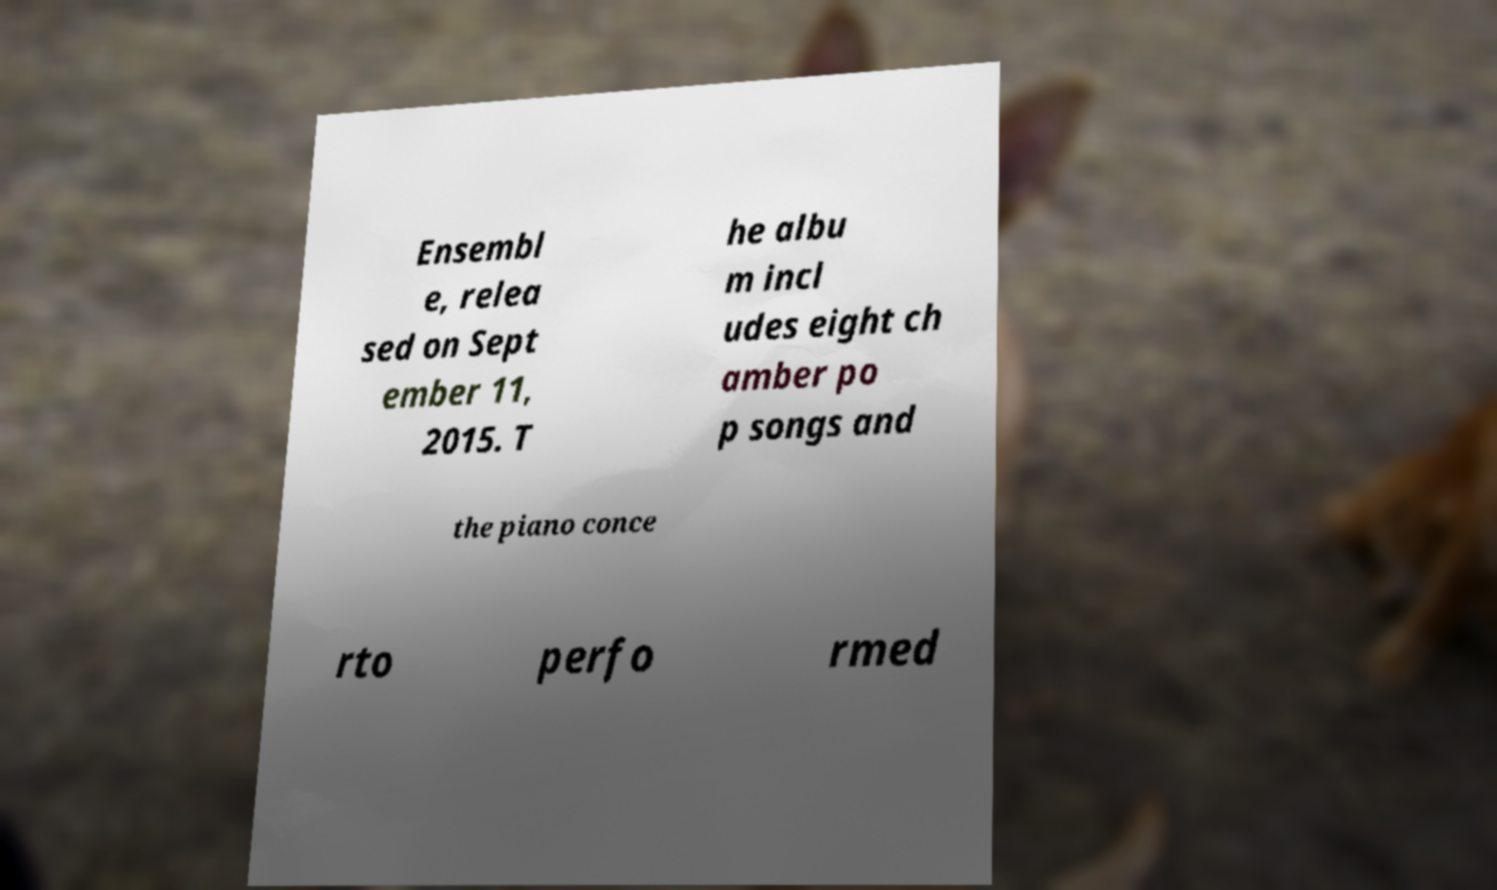Please read and relay the text visible in this image. What does it say? Ensembl e, relea sed on Sept ember 11, 2015. T he albu m incl udes eight ch amber po p songs and the piano conce rto perfo rmed 